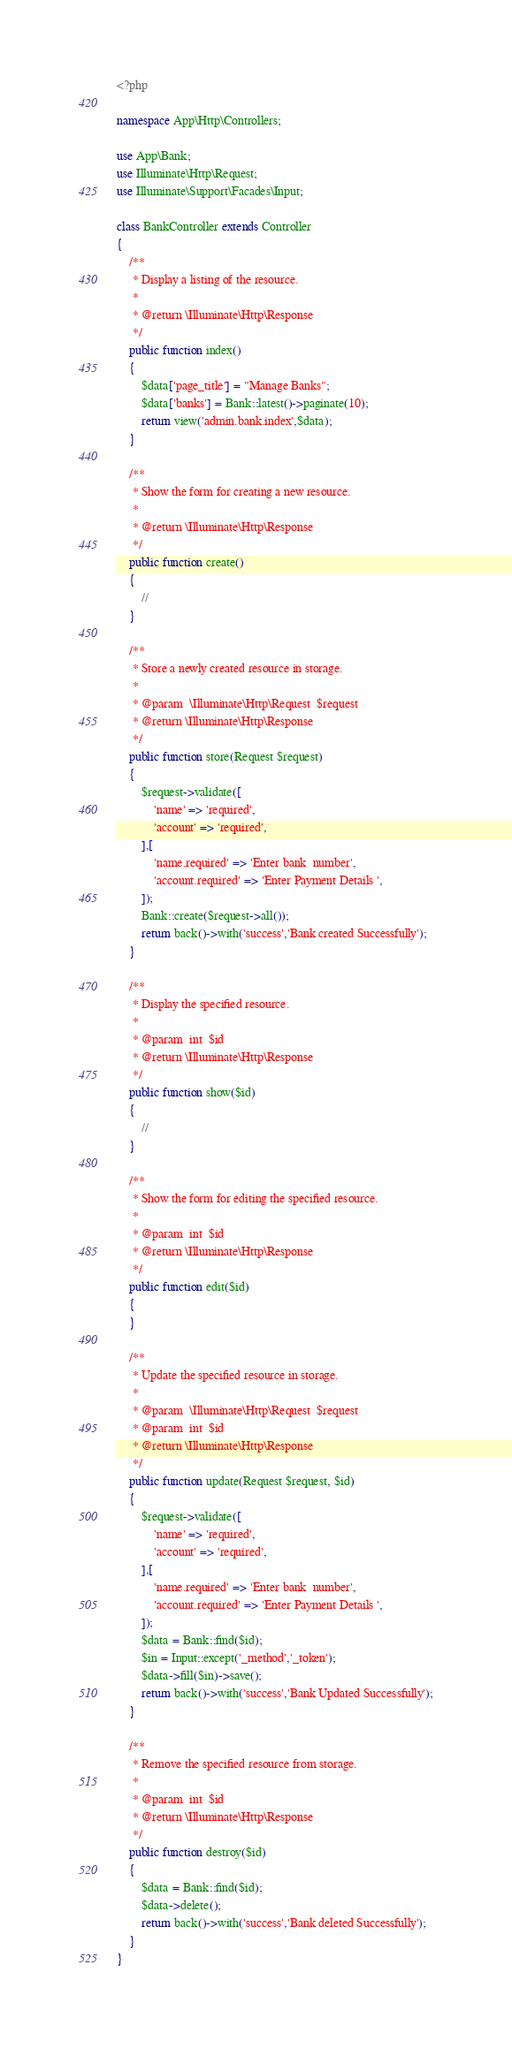Convert code to text. <code><loc_0><loc_0><loc_500><loc_500><_PHP_><?php

namespace App\Http\Controllers;

use App\Bank;
use Illuminate\Http\Request;
use Illuminate\Support\Facades\Input;

class BankController extends Controller
{
    /**
     * Display a listing of the resource.
     *
     * @return \Illuminate\Http\Response
     */
    public function index()
    {
        $data['page_title'] = "Manage Banks";
        $data['banks'] = Bank::latest()->paginate(10);
        return view('admin.bank.index',$data);
    }

    /**
     * Show the form for creating a new resource.
     *
     * @return \Illuminate\Http\Response
     */
    public function create()
    {
        //
    }

    /**
     * Store a newly created resource in storage.
     *
     * @param  \Illuminate\Http\Request  $request
     * @return \Illuminate\Http\Response
     */
    public function store(Request $request)
    {
        $request->validate([
            'name' => 'required',
            'account' => 'required',
        ],[
            'name.required' => 'Enter bank  number',
            'account.required' => 'Enter Payment Details ',
        ]);
        Bank::create($request->all());
        return back()->with('success','Bank created Successfully');
    }

    /**
     * Display the specified resource.
     *
     * @param  int  $id
     * @return \Illuminate\Http\Response
     */
    public function show($id)
    {
        //
    }

    /**
     * Show the form for editing the specified resource.
     *
     * @param  int  $id
     * @return \Illuminate\Http\Response
     */
    public function edit($id)
    {
    }

    /**
     * Update the specified resource in storage.
     *
     * @param  \Illuminate\Http\Request  $request
     * @param  int  $id
     * @return \Illuminate\Http\Response
     */
    public function update(Request $request, $id)
    {
        $request->validate([
            'name' => 'required',
            'account' => 'required',
        ],[
            'name.required' => 'Enter bank  number',
            'account.required' => 'Enter Payment Details ',
        ]);
        $data = Bank::find($id);
        $in = Input::except('_method','_token');
        $data->fill($in)->save();
        return back()->with('success','Bank Updated Successfully');
    }

    /**
     * Remove the specified resource from storage.
     *
     * @param  int  $id
     * @return \Illuminate\Http\Response
     */
    public function destroy($id)
    {
        $data = Bank::find($id);
        $data->delete();
        return back()->with('success','Bank deleted Successfully');
    }
}
</code> 